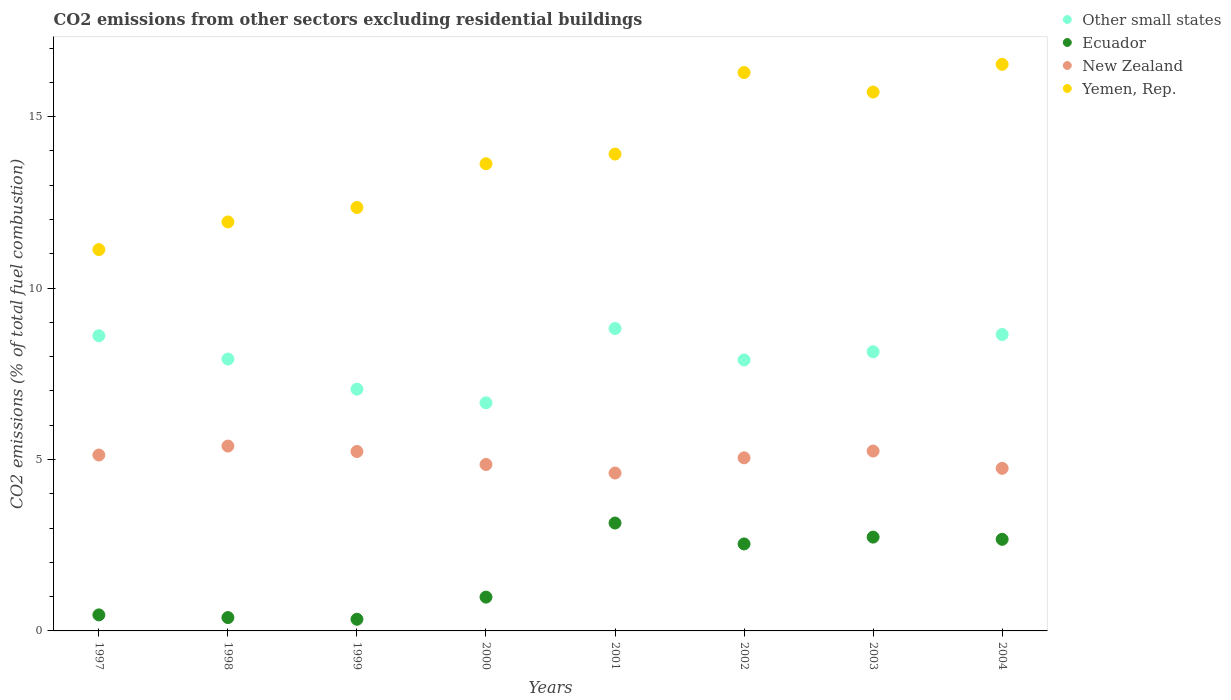How many different coloured dotlines are there?
Keep it short and to the point. 4. What is the total CO2 emitted in Yemen, Rep. in 1999?
Make the answer very short. 12.35. Across all years, what is the maximum total CO2 emitted in New Zealand?
Give a very brief answer. 5.39. Across all years, what is the minimum total CO2 emitted in Yemen, Rep.?
Provide a short and direct response. 11.12. In which year was the total CO2 emitted in New Zealand maximum?
Your answer should be very brief. 1998. What is the total total CO2 emitted in New Zealand in the graph?
Provide a succinct answer. 40.25. What is the difference between the total CO2 emitted in Other small states in 2000 and that in 2003?
Provide a succinct answer. -1.49. What is the difference between the total CO2 emitted in Yemen, Rep. in 2004 and the total CO2 emitted in Other small states in 1997?
Your answer should be compact. 7.92. What is the average total CO2 emitted in Other small states per year?
Offer a terse response. 7.97. In the year 1998, what is the difference between the total CO2 emitted in New Zealand and total CO2 emitted in Ecuador?
Your answer should be compact. 5. In how many years, is the total CO2 emitted in Ecuador greater than 15?
Offer a terse response. 0. What is the ratio of the total CO2 emitted in Ecuador in 1998 to that in 2003?
Your answer should be compact. 0.14. Is the total CO2 emitted in Other small states in 1999 less than that in 2004?
Give a very brief answer. Yes. What is the difference between the highest and the second highest total CO2 emitted in New Zealand?
Offer a very short reply. 0.15. What is the difference between the highest and the lowest total CO2 emitted in New Zealand?
Provide a succinct answer. 0.79. In how many years, is the total CO2 emitted in Other small states greater than the average total CO2 emitted in Other small states taken over all years?
Keep it short and to the point. 4. Is it the case that in every year, the sum of the total CO2 emitted in Other small states and total CO2 emitted in Yemen, Rep.  is greater than the sum of total CO2 emitted in Ecuador and total CO2 emitted in New Zealand?
Make the answer very short. Yes. Is it the case that in every year, the sum of the total CO2 emitted in Yemen, Rep. and total CO2 emitted in Other small states  is greater than the total CO2 emitted in Ecuador?
Provide a succinct answer. Yes. Is the total CO2 emitted in New Zealand strictly greater than the total CO2 emitted in Other small states over the years?
Offer a very short reply. No. How many years are there in the graph?
Your answer should be very brief. 8. What is the difference between two consecutive major ticks on the Y-axis?
Offer a terse response. 5. Does the graph contain any zero values?
Keep it short and to the point. No. Where does the legend appear in the graph?
Your response must be concise. Top right. How many legend labels are there?
Keep it short and to the point. 4. What is the title of the graph?
Keep it short and to the point. CO2 emissions from other sectors excluding residential buildings. What is the label or title of the X-axis?
Offer a very short reply. Years. What is the label or title of the Y-axis?
Your response must be concise. CO2 emissions (% of total fuel combustion). What is the CO2 emissions (% of total fuel combustion) of Other small states in 1997?
Provide a succinct answer. 8.61. What is the CO2 emissions (% of total fuel combustion) of Ecuador in 1997?
Provide a short and direct response. 0.47. What is the CO2 emissions (% of total fuel combustion) in New Zealand in 1997?
Provide a succinct answer. 5.13. What is the CO2 emissions (% of total fuel combustion) of Yemen, Rep. in 1997?
Offer a terse response. 11.12. What is the CO2 emissions (% of total fuel combustion) of Other small states in 1998?
Your answer should be compact. 7.93. What is the CO2 emissions (% of total fuel combustion) in Ecuador in 1998?
Your answer should be compact. 0.39. What is the CO2 emissions (% of total fuel combustion) in New Zealand in 1998?
Keep it short and to the point. 5.39. What is the CO2 emissions (% of total fuel combustion) of Yemen, Rep. in 1998?
Provide a succinct answer. 11.93. What is the CO2 emissions (% of total fuel combustion) in Other small states in 1999?
Offer a terse response. 7.05. What is the CO2 emissions (% of total fuel combustion) of Ecuador in 1999?
Your answer should be very brief. 0.34. What is the CO2 emissions (% of total fuel combustion) in New Zealand in 1999?
Give a very brief answer. 5.23. What is the CO2 emissions (% of total fuel combustion) in Yemen, Rep. in 1999?
Your response must be concise. 12.35. What is the CO2 emissions (% of total fuel combustion) of Other small states in 2000?
Offer a very short reply. 6.65. What is the CO2 emissions (% of total fuel combustion) in Ecuador in 2000?
Your response must be concise. 0.99. What is the CO2 emissions (% of total fuel combustion) of New Zealand in 2000?
Keep it short and to the point. 4.85. What is the CO2 emissions (% of total fuel combustion) in Yemen, Rep. in 2000?
Your response must be concise. 13.63. What is the CO2 emissions (% of total fuel combustion) of Other small states in 2001?
Keep it short and to the point. 8.82. What is the CO2 emissions (% of total fuel combustion) of Ecuador in 2001?
Give a very brief answer. 3.15. What is the CO2 emissions (% of total fuel combustion) of New Zealand in 2001?
Your response must be concise. 4.61. What is the CO2 emissions (% of total fuel combustion) of Yemen, Rep. in 2001?
Your answer should be compact. 13.91. What is the CO2 emissions (% of total fuel combustion) of Other small states in 2002?
Give a very brief answer. 7.9. What is the CO2 emissions (% of total fuel combustion) of Ecuador in 2002?
Give a very brief answer. 2.54. What is the CO2 emissions (% of total fuel combustion) of New Zealand in 2002?
Your answer should be very brief. 5.05. What is the CO2 emissions (% of total fuel combustion) in Yemen, Rep. in 2002?
Your answer should be compact. 16.29. What is the CO2 emissions (% of total fuel combustion) in Other small states in 2003?
Keep it short and to the point. 8.14. What is the CO2 emissions (% of total fuel combustion) in Ecuador in 2003?
Provide a succinct answer. 2.74. What is the CO2 emissions (% of total fuel combustion) in New Zealand in 2003?
Make the answer very short. 5.25. What is the CO2 emissions (% of total fuel combustion) in Yemen, Rep. in 2003?
Your response must be concise. 15.72. What is the CO2 emissions (% of total fuel combustion) of Other small states in 2004?
Provide a short and direct response. 8.65. What is the CO2 emissions (% of total fuel combustion) in Ecuador in 2004?
Ensure brevity in your answer.  2.67. What is the CO2 emissions (% of total fuel combustion) in New Zealand in 2004?
Offer a terse response. 4.74. What is the CO2 emissions (% of total fuel combustion) in Yemen, Rep. in 2004?
Your answer should be compact. 16.53. Across all years, what is the maximum CO2 emissions (% of total fuel combustion) of Other small states?
Provide a succinct answer. 8.82. Across all years, what is the maximum CO2 emissions (% of total fuel combustion) in Ecuador?
Your answer should be very brief. 3.15. Across all years, what is the maximum CO2 emissions (% of total fuel combustion) in New Zealand?
Your answer should be very brief. 5.39. Across all years, what is the maximum CO2 emissions (% of total fuel combustion) of Yemen, Rep.?
Make the answer very short. 16.53. Across all years, what is the minimum CO2 emissions (% of total fuel combustion) in Other small states?
Provide a succinct answer. 6.65. Across all years, what is the minimum CO2 emissions (% of total fuel combustion) of Ecuador?
Offer a terse response. 0.34. Across all years, what is the minimum CO2 emissions (% of total fuel combustion) in New Zealand?
Provide a short and direct response. 4.61. Across all years, what is the minimum CO2 emissions (% of total fuel combustion) of Yemen, Rep.?
Keep it short and to the point. 11.12. What is the total CO2 emissions (% of total fuel combustion) in Other small states in the graph?
Offer a very short reply. 63.76. What is the total CO2 emissions (% of total fuel combustion) of Ecuador in the graph?
Offer a terse response. 13.27. What is the total CO2 emissions (% of total fuel combustion) in New Zealand in the graph?
Your answer should be very brief. 40.25. What is the total CO2 emissions (% of total fuel combustion) in Yemen, Rep. in the graph?
Provide a succinct answer. 111.46. What is the difference between the CO2 emissions (% of total fuel combustion) in Other small states in 1997 and that in 1998?
Offer a terse response. 0.68. What is the difference between the CO2 emissions (% of total fuel combustion) of Ecuador in 1997 and that in 1998?
Give a very brief answer. 0.08. What is the difference between the CO2 emissions (% of total fuel combustion) in New Zealand in 1997 and that in 1998?
Keep it short and to the point. -0.26. What is the difference between the CO2 emissions (% of total fuel combustion) of Yemen, Rep. in 1997 and that in 1998?
Offer a terse response. -0.81. What is the difference between the CO2 emissions (% of total fuel combustion) in Other small states in 1997 and that in 1999?
Give a very brief answer. 1.56. What is the difference between the CO2 emissions (% of total fuel combustion) of Ecuador in 1997 and that in 1999?
Your response must be concise. 0.13. What is the difference between the CO2 emissions (% of total fuel combustion) in New Zealand in 1997 and that in 1999?
Your response must be concise. -0.1. What is the difference between the CO2 emissions (% of total fuel combustion) of Yemen, Rep. in 1997 and that in 1999?
Offer a terse response. -1.23. What is the difference between the CO2 emissions (% of total fuel combustion) in Other small states in 1997 and that in 2000?
Provide a succinct answer. 1.96. What is the difference between the CO2 emissions (% of total fuel combustion) of Ecuador in 1997 and that in 2000?
Give a very brief answer. -0.52. What is the difference between the CO2 emissions (% of total fuel combustion) in New Zealand in 1997 and that in 2000?
Your response must be concise. 0.28. What is the difference between the CO2 emissions (% of total fuel combustion) in Yemen, Rep. in 1997 and that in 2000?
Your answer should be compact. -2.5. What is the difference between the CO2 emissions (% of total fuel combustion) of Other small states in 1997 and that in 2001?
Offer a very short reply. -0.21. What is the difference between the CO2 emissions (% of total fuel combustion) of Ecuador in 1997 and that in 2001?
Provide a short and direct response. -2.68. What is the difference between the CO2 emissions (% of total fuel combustion) in New Zealand in 1997 and that in 2001?
Offer a very short reply. 0.52. What is the difference between the CO2 emissions (% of total fuel combustion) of Yemen, Rep. in 1997 and that in 2001?
Keep it short and to the point. -2.79. What is the difference between the CO2 emissions (% of total fuel combustion) of Other small states in 1997 and that in 2002?
Provide a short and direct response. 0.71. What is the difference between the CO2 emissions (% of total fuel combustion) in Ecuador in 1997 and that in 2002?
Offer a terse response. -2.07. What is the difference between the CO2 emissions (% of total fuel combustion) in New Zealand in 1997 and that in 2002?
Your answer should be very brief. 0.08. What is the difference between the CO2 emissions (% of total fuel combustion) in Yemen, Rep. in 1997 and that in 2002?
Keep it short and to the point. -5.16. What is the difference between the CO2 emissions (% of total fuel combustion) of Other small states in 1997 and that in 2003?
Make the answer very short. 0.47. What is the difference between the CO2 emissions (% of total fuel combustion) in Ecuador in 1997 and that in 2003?
Give a very brief answer. -2.27. What is the difference between the CO2 emissions (% of total fuel combustion) of New Zealand in 1997 and that in 2003?
Give a very brief answer. -0.12. What is the difference between the CO2 emissions (% of total fuel combustion) of Yemen, Rep. in 1997 and that in 2003?
Your answer should be compact. -4.59. What is the difference between the CO2 emissions (% of total fuel combustion) of Other small states in 1997 and that in 2004?
Give a very brief answer. -0.04. What is the difference between the CO2 emissions (% of total fuel combustion) of Ecuador in 1997 and that in 2004?
Your answer should be compact. -2.2. What is the difference between the CO2 emissions (% of total fuel combustion) in New Zealand in 1997 and that in 2004?
Offer a terse response. 0.39. What is the difference between the CO2 emissions (% of total fuel combustion) of Yemen, Rep. in 1997 and that in 2004?
Your answer should be very brief. -5.4. What is the difference between the CO2 emissions (% of total fuel combustion) in Other small states in 1998 and that in 1999?
Keep it short and to the point. 0.88. What is the difference between the CO2 emissions (% of total fuel combustion) in Ecuador in 1998 and that in 1999?
Offer a terse response. 0.05. What is the difference between the CO2 emissions (% of total fuel combustion) of New Zealand in 1998 and that in 1999?
Keep it short and to the point. 0.16. What is the difference between the CO2 emissions (% of total fuel combustion) in Yemen, Rep. in 1998 and that in 1999?
Give a very brief answer. -0.42. What is the difference between the CO2 emissions (% of total fuel combustion) of Other small states in 1998 and that in 2000?
Offer a terse response. 1.28. What is the difference between the CO2 emissions (% of total fuel combustion) of Ecuador in 1998 and that in 2000?
Offer a terse response. -0.6. What is the difference between the CO2 emissions (% of total fuel combustion) in New Zealand in 1998 and that in 2000?
Ensure brevity in your answer.  0.54. What is the difference between the CO2 emissions (% of total fuel combustion) in Yemen, Rep. in 1998 and that in 2000?
Ensure brevity in your answer.  -1.7. What is the difference between the CO2 emissions (% of total fuel combustion) of Other small states in 1998 and that in 2001?
Your answer should be compact. -0.89. What is the difference between the CO2 emissions (% of total fuel combustion) in Ecuador in 1998 and that in 2001?
Your answer should be very brief. -2.76. What is the difference between the CO2 emissions (% of total fuel combustion) in New Zealand in 1998 and that in 2001?
Your answer should be compact. 0.79. What is the difference between the CO2 emissions (% of total fuel combustion) of Yemen, Rep. in 1998 and that in 2001?
Give a very brief answer. -1.98. What is the difference between the CO2 emissions (% of total fuel combustion) in Other small states in 1998 and that in 2002?
Your answer should be very brief. 0.03. What is the difference between the CO2 emissions (% of total fuel combustion) in Ecuador in 1998 and that in 2002?
Keep it short and to the point. -2.15. What is the difference between the CO2 emissions (% of total fuel combustion) of New Zealand in 1998 and that in 2002?
Ensure brevity in your answer.  0.34. What is the difference between the CO2 emissions (% of total fuel combustion) of Yemen, Rep. in 1998 and that in 2002?
Ensure brevity in your answer.  -4.36. What is the difference between the CO2 emissions (% of total fuel combustion) of Other small states in 1998 and that in 2003?
Ensure brevity in your answer.  -0.21. What is the difference between the CO2 emissions (% of total fuel combustion) of Ecuador in 1998 and that in 2003?
Make the answer very short. -2.35. What is the difference between the CO2 emissions (% of total fuel combustion) in New Zealand in 1998 and that in 2003?
Your answer should be compact. 0.15. What is the difference between the CO2 emissions (% of total fuel combustion) of Yemen, Rep. in 1998 and that in 2003?
Your response must be concise. -3.79. What is the difference between the CO2 emissions (% of total fuel combustion) in Other small states in 1998 and that in 2004?
Ensure brevity in your answer.  -0.72. What is the difference between the CO2 emissions (% of total fuel combustion) of Ecuador in 1998 and that in 2004?
Make the answer very short. -2.28. What is the difference between the CO2 emissions (% of total fuel combustion) of New Zealand in 1998 and that in 2004?
Your answer should be very brief. 0.65. What is the difference between the CO2 emissions (% of total fuel combustion) of Yemen, Rep. in 1998 and that in 2004?
Your answer should be very brief. -4.6. What is the difference between the CO2 emissions (% of total fuel combustion) of Other small states in 1999 and that in 2000?
Offer a very short reply. 0.4. What is the difference between the CO2 emissions (% of total fuel combustion) of Ecuador in 1999 and that in 2000?
Offer a very short reply. -0.65. What is the difference between the CO2 emissions (% of total fuel combustion) in New Zealand in 1999 and that in 2000?
Provide a short and direct response. 0.38. What is the difference between the CO2 emissions (% of total fuel combustion) of Yemen, Rep. in 1999 and that in 2000?
Ensure brevity in your answer.  -1.28. What is the difference between the CO2 emissions (% of total fuel combustion) in Other small states in 1999 and that in 2001?
Give a very brief answer. -1.77. What is the difference between the CO2 emissions (% of total fuel combustion) in Ecuador in 1999 and that in 2001?
Keep it short and to the point. -2.81. What is the difference between the CO2 emissions (% of total fuel combustion) in New Zealand in 1999 and that in 2001?
Provide a succinct answer. 0.63. What is the difference between the CO2 emissions (% of total fuel combustion) in Yemen, Rep. in 1999 and that in 2001?
Ensure brevity in your answer.  -1.56. What is the difference between the CO2 emissions (% of total fuel combustion) in Other small states in 1999 and that in 2002?
Your response must be concise. -0.85. What is the difference between the CO2 emissions (% of total fuel combustion) in Ecuador in 1999 and that in 2002?
Give a very brief answer. -2.2. What is the difference between the CO2 emissions (% of total fuel combustion) in New Zealand in 1999 and that in 2002?
Your response must be concise. 0.18. What is the difference between the CO2 emissions (% of total fuel combustion) in Yemen, Rep. in 1999 and that in 2002?
Provide a succinct answer. -3.94. What is the difference between the CO2 emissions (% of total fuel combustion) of Other small states in 1999 and that in 2003?
Your answer should be very brief. -1.09. What is the difference between the CO2 emissions (% of total fuel combustion) in Ecuador in 1999 and that in 2003?
Ensure brevity in your answer.  -2.4. What is the difference between the CO2 emissions (% of total fuel combustion) in New Zealand in 1999 and that in 2003?
Your answer should be compact. -0.01. What is the difference between the CO2 emissions (% of total fuel combustion) of Yemen, Rep. in 1999 and that in 2003?
Your answer should be compact. -3.37. What is the difference between the CO2 emissions (% of total fuel combustion) of Other small states in 1999 and that in 2004?
Provide a succinct answer. -1.59. What is the difference between the CO2 emissions (% of total fuel combustion) in Ecuador in 1999 and that in 2004?
Offer a very short reply. -2.33. What is the difference between the CO2 emissions (% of total fuel combustion) of New Zealand in 1999 and that in 2004?
Give a very brief answer. 0.49. What is the difference between the CO2 emissions (% of total fuel combustion) in Yemen, Rep. in 1999 and that in 2004?
Make the answer very short. -4.18. What is the difference between the CO2 emissions (% of total fuel combustion) in Other small states in 2000 and that in 2001?
Offer a very short reply. -2.17. What is the difference between the CO2 emissions (% of total fuel combustion) of Ecuador in 2000 and that in 2001?
Give a very brief answer. -2.16. What is the difference between the CO2 emissions (% of total fuel combustion) in New Zealand in 2000 and that in 2001?
Offer a very short reply. 0.25. What is the difference between the CO2 emissions (% of total fuel combustion) of Yemen, Rep. in 2000 and that in 2001?
Ensure brevity in your answer.  -0.28. What is the difference between the CO2 emissions (% of total fuel combustion) of Other small states in 2000 and that in 2002?
Provide a succinct answer. -1.25. What is the difference between the CO2 emissions (% of total fuel combustion) in Ecuador in 2000 and that in 2002?
Your answer should be very brief. -1.55. What is the difference between the CO2 emissions (% of total fuel combustion) of New Zealand in 2000 and that in 2002?
Offer a very short reply. -0.19. What is the difference between the CO2 emissions (% of total fuel combustion) in Yemen, Rep. in 2000 and that in 2002?
Your answer should be very brief. -2.66. What is the difference between the CO2 emissions (% of total fuel combustion) in Other small states in 2000 and that in 2003?
Your answer should be compact. -1.49. What is the difference between the CO2 emissions (% of total fuel combustion) in Ecuador in 2000 and that in 2003?
Offer a terse response. -1.75. What is the difference between the CO2 emissions (% of total fuel combustion) in New Zealand in 2000 and that in 2003?
Your answer should be compact. -0.39. What is the difference between the CO2 emissions (% of total fuel combustion) of Yemen, Rep. in 2000 and that in 2003?
Ensure brevity in your answer.  -2.09. What is the difference between the CO2 emissions (% of total fuel combustion) of Other small states in 2000 and that in 2004?
Give a very brief answer. -1.99. What is the difference between the CO2 emissions (% of total fuel combustion) in Ecuador in 2000 and that in 2004?
Offer a very short reply. -1.69. What is the difference between the CO2 emissions (% of total fuel combustion) of New Zealand in 2000 and that in 2004?
Your response must be concise. 0.11. What is the difference between the CO2 emissions (% of total fuel combustion) of Yemen, Rep. in 2000 and that in 2004?
Ensure brevity in your answer.  -2.9. What is the difference between the CO2 emissions (% of total fuel combustion) in Other small states in 2001 and that in 2002?
Your answer should be very brief. 0.92. What is the difference between the CO2 emissions (% of total fuel combustion) of Ecuador in 2001 and that in 2002?
Your response must be concise. 0.61. What is the difference between the CO2 emissions (% of total fuel combustion) of New Zealand in 2001 and that in 2002?
Your answer should be very brief. -0.44. What is the difference between the CO2 emissions (% of total fuel combustion) in Yemen, Rep. in 2001 and that in 2002?
Your answer should be very brief. -2.38. What is the difference between the CO2 emissions (% of total fuel combustion) in Other small states in 2001 and that in 2003?
Make the answer very short. 0.68. What is the difference between the CO2 emissions (% of total fuel combustion) of Ecuador in 2001 and that in 2003?
Offer a terse response. 0.41. What is the difference between the CO2 emissions (% of total fuel combustion) in New Zealand in 2001 and that in 2003?
Give a very brief answer. -0.64. What is the difference between the CO2 emissions (% of total fuel combustion) of Yemen, Rep. in 2001 and that in 2003?
Offer a terse response. -1.81. What is the difference between the CO2 emissions (% of total fuel combustion) in Other small states in 2001 and that in 2004?
Provide a short and direct response. 0.18. What is the difference between the CO2 emissions (% of total fuel combustion) in Ecuador in 2001 and that in 2004?
Make the answer very short. 0.48. What is the difference between the CO2 emissions (% of total fuel combustion) in New Zealand in 2001 and that in 2004?
Offer a very short reply. -0.14. What is the difference between the CO2 emissions (% of total fuel combustion) in Yemen, Rep. in 2001 and that in 2004?
Give a very brief answer. -2.62. What is the difference between the CO2 emissions (% of total fuel combustion) of Other small states in 2002 and that in 2003?
Provide a succinct answer. -0.24. What is the difference between the CO2 emissions (% of total fuel combustion) in Ecuador in 2002 and that in 2003?
Your response must be concise. -0.2. What is the difference between the CO2 emissions (% of total fuel combustion) in New Zealand in 2002 and that in 2003?
Offer a terse response. -0.2. What is the difference between the CO2 emissions (% of total fuel combustion) of Yemen, Rep. in 2002 and that in 2003?
Offer a very short reply. 0.57. What is the difference between the CO2 emissions (% of total fuel combustion) of Other small states in 2002 and that in 2004?
Provide a succinct answer. -0.74. What is the difference between the CO2 emissions (% of total fuel combustion) of Ecuador in 2002 and that in 2004?
Provide a short and direct response. -0.13. What is the difference between the CO2 emissions (% of total fuel combustion) of New Zealand in 2002 and that in 2004?
Keep it short and to the point. 0.31. What is the difference between the CO2 emissions (% of total fuel combustion) of Yemen, Rep. in 2002 and that in 2004?
Provide a short and direct response. -0.24. What is the difference between the CO2 emissions (% of total fuel combustion) of Other small states in 2003 and that in 2004?
Your answer should be very brief. -0.5. What is the difference between the CO2 emissions (% of total fuel combustion) of Ecuador in 2003 and that in 2004?
Your answer should be compact. 0.07. What is the difference between the CO2 emissions (% of total fuel combustion) of New Zealand in 2003 and that in 2004?
Provide a short and direct response. 0.5. What is the difference between the CO2 emissions (% of total fuel combustion) of Yemen, Rep. in 2003 and that in 2004?
Keep it short and to the point. -0.81. What is the difference between the CO2 emissions (% of total fuel combustion) in Other small states in 1997 and the CO2 emissions (% of total fuel combustion) in Ecuador in 1998?
Ensure brevity in your answer.  8.22. What is the difference between the CO2 emissions (% of total fuel combustion) in Other small states in 1997 and the CO2 emissions (% of total fuel combustion) in New Zealand in 1998?
Give a very brief answer. 3.22. What is the difference between the CO2 emissions (% of total fuel combustion) of Other small states in 1997 and the CO2 emissions (% of total fuel combustion) of Yemen, Rep. in 1998?
Ensure brevity in your answer.  -3.32. What is the difference between the CO2 emissions (% of total fuel combustion) of Ecuador in 1997 and the CO2 emissions (% of total fuel combustion) of New Zealand in 1998?
Your answer should be very brief. -4.92. What is the difference between the CO2 emissions (% of total fuel combustion) in Ecuador in 1997 and the CO2 emissions (% of total fuel combustion) in Yemen, Rep. in 1998?
Your answer should be compact. -11.46. What is the difference between the CO2 emissions (% of total fuel combustion) in New Zealand in 1997 and the CO2 emissions (% of total fuel combustion) in Yemen, Rep. in 1998?
Keep it short and to the point. -6.8. What is the difference between the CO2 emissions (% of total fuel combustion) in Other small states in 1997 and the CO2 emissions (% of total fuel combustion) in Ecuador in 1999?
Offer a very short reply. 8.27. What is the difference between the CO2 emissions (% of total fuel combustion) in Other small states in 1997 and the CO2 emissions (% of total fuel combustion) in New Zealand in 1999?
Your response must be concise. 3.38. What is the difference between the CO2 emissions (% of total fuel combustion) of Other small states in 1997 and the CO2 emissions (% of total fuel combustion) of Yemen, Rep. in 1999?
Ensure brevity in your answer.  -3.74. What is the difference between the CO2 emissions (% of total fuel combustion) in Ecuador in 1997 and the CO2 emissions (% of total fuel combustion) in New Zealand in 1999?
Offer a very short reply. -4.77. What is the difference between the CO2 emissions (% of total fuel combustion) of Ecuador in 1997 and the CO2 emissions (% of total fuel combustion) of Yemen, Rep. in 1999?
Provide a short and direct response. -11.88. What is the difference between the CO2 emissions (% of total fuel combustion) of New Zealand in 1997 and the CO2 emissions (% of total fuel combustion) of Yemen, Rep. in 1999?
Your answer should be very brief. -7.22. What is the difference between the CO2 emissions (% of total fuel combustion) of Other small states in 1997 and the CO2 emissions (% of total fuel combustion) of Ecuador in 2000?
Make the answer very short. 7.62. What is the difference between the CO2 emissions (% of total fuel combustion) of Other small states in 1997 and the CO2 emissions (% of total fuel combustion) of New Zealand in 2000?
Provide a short and direct response. 3.76. What is the difference between the CO2 emissions (% of total fuel combustion) in Other small states in 1997 and the CO2 emissions (% of total fuel combustion) in Yemen, Rep. in 2000?
Your answer should be very brief. -5.02. What is the difference between the CO2 emissions (% of total fuel combustion) of Ecuador in 1997 and the CO2 emissions (% of total fuel combustion) of New Zealand in 2000?
Offer a terse response. -4.39. What is the difference between the CO2 emissions (% of total fuel combustion) of Ecuador in 1997 and the CO2 emissions (% of total fuel combustion) of Yemen, Rep. in 2000?
Give a very brief answer. -13.16. What is the difference between the CO2 emissions (% of total fuel combustion) in New Zealand in 1997 and the CO2 emissions (% of total fuel combustion) in Yemen, Rep. in 2000?
Give a very brief answer. -8.5. What is the difference between the CO2 emissions (% of total fuel combustion) of Other small states in 1997 and the CO2 emissions (% of total fuel combustion) of Ecuador in 2001?
Offer a very short reply. 5.46. What is the difference between the CO2 emissions (% of total fuel combustion) of Other small states in 1997 and the CO2 emissions (% of total fuel combustion) of New Zealand in 2001?
Offer a terse response. 4. What is the difference between the CO2 emissions (% of total fuel combustion) of Other small states in 1997 and the CO2 emissions (% of total fuel combustion) of Yemen, Rep. in 2001?
Your answer should be very brief. -5.3. What is the difference between the CO2 emissions (% of total fuel combustion) in Ecuador in 1997 and the CO2 emissions (% of total fuel combustion) in New Zealand in 2001?
Provide a short and direct response. -4.14. What is the difference between the CO2 emissions (% of total fuel combustion) of Ecuador in 1997 and the CO2 emissions (% of total fuel combustion) of Yemen, Rep. in 2001?
Your answer should be very brief. -13.44. What is the difference between the CO2 emissions (% of total fuel combustion) of New Zealand in 1997 and the CO2 emissions (% of total fuel combustion) of Yemen, Rep. in 2001?
Your response must be concise. -8.78. What is the difference between the CO2 emissions (% of total fuel combustion) of Other small states in 1997 and the CO2 emissions (% of total fuel combustion) of Ecuador in 2002?
Give a very brief answer. 6.07. What is the difference between the CO2 emissions (% of total fuel combustion) of Other small states in 1997 and the CO2 emissions (% of total fuel combustion) of New Zealand in 2002?
Your answer should be compact. 3.56. What is the difference between the CO2 emissions (% of total fuel combustion) of Other small states in 1997 and the CO2 emissions (% of total fuel combustion) of Yemen, Rep. in 2002?
Provide a succinct answer. -7.68. What is the difference between the CO2 emissions (% of total fuel combustion) in Ecuador in 1997 and the CO2 emissions (% of total fuel combustion) in New Zealand in 2002?
Your answer should be compact. -4.58. What is the difference between the CO2 emissions (% of total fuel combustion) of Ecuador in 1997 and the CO2 emissions (% of total fuel combustion) of Yemen, Rep. in 2002?
Offer a very short reply. -15.82. What is the difference between the CO2 emissions (% of total fuel combustion) of New Zealand in 1997 and the CO2 emissions (% of total fuel combustion) of Yemen, Rep. in 2002?
Your answer should be very brief. -11.16. What is the difference between the CO2 emissions (% of total fuel combustion) in Other small states in 1997 and the CO2 emissions (% of total fuel combustion) in Ecuador in 2003?
Make the answer very short. 5.87. What is the difference between the CO2 emissions (% of total fuel combustion) of Other small states in 1997 and the CO2 emissions (% of total fuel combustion) of New Zealand in 2003?
Your response must be concise. 3.36. What is the difference between the CO2 emissions (% of total fuel combustion) in Other small states in 1997 and the CO2 emissions (% of total fuel combustion) in Yemen, Rep. in 2003?
Keep it short and to the point. -7.11. What is the difference between the CO2 emissions (% of total fuel combustion) in Ecuador in 1997 and the CO2 emissions (% of total fuel combustion) in New Zealand in 2003?
Keep it short and to the point. -4.78. What is the difference between the CO2 emissions (% of total fuel combustion) in Ecuador in 1997 and the CO2 emissions (% of total fuel combustion) in Yemen, Rep. in 2003?
Ensure brevity in your answer.  -15.25. What is the difference between the CO2 emissions (% of total fuel combustion) in New Zealand in 1997 and the CO2 emissions (% of total fuel combustion) in Yemen, Rep. in 2003?
Offer a terse response. -10.59. What is the difference between the CO2 emissions (% of total fuel combustion) of Other small states in 1997 and the CO2 emissions (% of total fuel combustion) of Ecuador in 2004?
Provide a succinct answer. 5.94. What is the difference between the CO2 emissions (% of total fuel combustion) in Other small states in 1997 and the CO2 emissions (% of total fuel combustion) in New Zealand in 2004?
Provide a short and direct response. 3.87. What is the difference between the CO2 emissions (% of total fuel combustion) in Other small states in 1997 and the CO2 emissions (% of total fuel combustion) in Yemen, Rep. in 2004?
Offer a very short reply. -7.92. What is the difference between the CO2 emissions (% of total fuel combustion) in Ecuador in 1997 and the CO2 emissions (% of total fuel combustion) in New Zealand in 2004?
Your response must be concise. -4.27. What is the difference between the CO2 emissions (% of total fuel combustion) in Ecuador in 1997 and the CO2 emissions (% of total fuel combustion) in Yemen, Rep. in 2004?
Offer a very short reply. -16.06. What is the difference between the CO2 emissions (% of total fuel combustion) in New Zealand in 1997 and the CO2 emissions (% of total fuel combustion) in Yemen, Rep. in 2004?
Your answer should be very brief. -11.4. What is the difference between the CO2 emissions (% of total fuel combustion) of Other small states in 1998 and the CO2 emissions (% of total fuel combustion) of Ecuador in 1999?
Make the answer very short. 7.59. What is the difference between the CO2 emissions (% of total fuel combustion) in Other small states in 1998 and the CO2 emissions (% of total fuel combustion) in New Zealand in 1999?
Ensure brevity in your answer.  2.7. What is the difference between the CO2 emissions (% of total fuel combustion) of Other small states in 1998 and the CO2 emissions (% of total fuel combustion) of Yemen, Rep. in 1999?
Offer a terse response. -4.42. What is the difference between the CO2 emissions (% of total fuel combustion) in Ecuador in 1998 and the CO2 emissions (% of total fuel combustion) in New Zealand in 1999?
Offer a terse response. -4.84. What is the difference between the CO2 emissions (% of total fuel combustion) in Ecuador in 1998 and the CO2 emissions (% of total fuel combustion) in Yemen, Rep. in 1999?
Your answer should be very brief. -11.96. What is the difference between the CO2 emissions (% of total fuel combustion) in New Zealand in 1998 and the CO2 emissions (% of total fuel combustion) in Yemen, Rep. in 1999?
Your answer should be compact. -6.96. What is the difference between the CO2 emissions (% of total fuel combustion) in Other small states in 1998 and the CO2 emissions (% of total fuel combustion) in Ecuador in 2000?
Provide a short and direct response. 6.94. What is the difference between the CO2 emissions (% of total fuel combustion) in Other small states in 1998 and the CO2 emissions (% of total fuel combustion) in New Zealand in 2000?
Offer a terse response. 3.08. What is the difference between the CO2 emissions (% of total fuel combustion) in Other small states in 1998 and the CO2 emissions (% of total fuel combustion) in Yemen, Rep. in 2000?
Provide a succinct answer. -5.7. What is the difference between the CO2 emissions (% of total fuel combustion) of Ecuador in 1998 and the CO2 emissions (% of total fuel combustion) of New Zealand in 2000?
Provide a short and direct response. -4.46. What is the difference between the CO2 emissions (% of total fuel combustion) in Ecuador in 1998 and the CO2 emissions (% of total fuel combustion) in Yemen, Rep. in 2000?
Offer a terse response. -13.24. What is the difference between the CO2 emissions (% of total fuel combustion) of New Zealand in 1998 and the CO2 emissions (% of total fuel combustion) of Yemen, Rep. in 2000?
Make the answer very short. -8.23. What is the difference between the CO2 emissions (% of total fuel combustion) in Other small states in 1998 and the CO2 emissions (% of total fuel combustion) in Ecuador in 2001?
Provide a succinct answer. 4.78. What is the difference between the CO2 emissions (% of total fuel combustion) of Other small states in 1998 and the CO2 emissions (% of total fuel combustion) of New Zealand in 2001?
Give a very brief answer. 3.32. What is the difference between the CO2 emissions (% of total fuel combustion) of Other small states in 1998 and the CO2 emissions (% of total fuel combustion) of Yemen, Rep. in 2001?
Ensure brevity in your answer.  -5.98. What is the difference between the CO2 emissions (% of total fuel combustion) in Ecuador in 1998 and the CO2 emissions (% of total fuel combustion) in New Zealand in 2001?
Provide a short and direct response. -4.22. What is the difference between the CO2 emissions (% of total fuel combustion) of Ecuador in 1998 and the CO2 emissions (% of total fuel combustion) of Yemen, Rep. in 2001?
Ensure brevity in your answer.  -13.52. What is the difference between the CO2 emissions (% of total fuel combustion) in New Zealand in 1998 and the CO2 emissions (% of total fuel combustion) in Yemen, Rep. in 2001?
Your response must be concise. -8.52. What is the difference between the CO2 emissions (% of total fuel combustion) of Other small states in 1998 and the CO2 emissions (% of total fuel combustion) of Ecuador in 2002?
Your answer should be very brief. 5.39. What is the difference between the CO2 emissions (% of total fuel combustion) in Other small states in 1998 and the CO2 emissions (% of total fuel combustion) in New Zealand in 2002?
Your response must be concise. 2.88. What is the difference between the CO2 emissions (% of total fuel combustion) in Other small states in 1998 and the CO2 emissions (% of total fuel combustion) in Yemen, Rep. in 2002?
Offer a very short reply. -8.36. What is the difference between the CO2 emissions (% of total fuel combustion) of Ecuador in 1998 and the CO2 emissions (% of total fuel combustion) of New Zealand in 2002?
Give a very brief answer. -4.66. What is the difference between the CO2 emissions (% of total fuel combustion) of Ecuador in 1998 and the CO2 emissions (% of total fuel combustion) of Yemen, Rep. in 2002?
Your answer should be very brief. -15.9. What is the difference between the CO2 emissions (% of total fuel combustion) of New Zealand in 1998 and the CO2 emissions (% of total fuel combustion) of Yemen, Rep. in 2002?
Give a very brief answer. -10.89. What is the difference between the CO2 emissions (% of total fuel combustion) in Other small states in 1998 and the CO2 emissions (% of total fuel combustion) in Ecuador in 2003?
Provide a short and direct response. 5.19. What is the difference between the CO2 emissions (% of total fuel combustion) of Other small states in 1998 and the CO2 emissions (% of total fuel combustion) of New Zealand in 2003?
Provide a short and direct response. 2.68. What is the difference between the CO2 emissions (% of total fuel combustion) of Other small states in 1998 and the CO2 emissions (% of total fuel combustion) of Yemen, Rep. in 2003?
Ensure brevity in your answer.  -7.79. What is the difference between the CO2 emissions (% of total fuel combustion) in Ecuador in 1998 and the CO2 emissions (% of total fuel combustion) in New Zealand in 2003?
Your response must be concise. -4.86. What is the difference between the CO2 emissions (% of total fuel combustion) in Ecuador in 1998 and the CO2 emissions (% of total fuel combustion) in Yemen, Rep. in 2003?
Give a very brief answer. -15.33. What is the difference between the CO2 emissions (% of total fuel combustion) of New Zealand in 1998 and the CO2 emissions (% of total fuel combustion) of Yemen, Rep. in 2003?
Your answer should be compact. -10.32. What is the difference between the CO2 emissions (% of total fuel combustion) of Other small states in 1998 and the CO2 emissions (% of total fuel combustion) of Ecuador in 2004?
Provide a short and direct response. 5.26. What is the difference between the CO2 emissions (% of total fuel combustion) in Other small states in 1998 and the CO2 emissions (% of total fuel combustion) in New Zealand in 2004?
Keep it short and to the point. 3.19. What is the difference between the CO2 emissions (% of total fuel combustion) in Other small states in 1998 and the CO2 emissions (% of total fuel combustion) in Yemen, Rep. in 2004?
Offer a terse response. -8.6. What is the difference between the CO2 emissions (% of total fuel combustion) in Ecuador in 1998 and the CO2 emissions (% of total fuel combustion) in New Zealand in 2004?
Offer a very short reply. -4.35. What is the difference between the CO2 emissions (% of total fuel combustion) in Ecuador in 1998 and the CO2 emissions (% of total fuel combustion) in Yemen, Rep. in 2004?
Your answer should be compact. -16.14. What is the difference between the CO2 emissions (% of total fuel combustion) in New Zealand in 1998 and the CO2 emissions (% of total fuel combustion) in Yemen, Rep. in 2004?
Make the answer very short. -11.13. What is the difference between the CO2 emissions (% of total fuel combustion) of Other small states in 1999 and the CO2 emissions (% of total fuel combustion) of Ecuador in 2000?
Provide a short and direct response. 6.07. What is the difference between the CO2 emissions (% of total fuel combustion) of Other small states in 1999 and the CO2 emissions (% of total fuel combustion) of New Zealand in 2000?
Make the answer very short. 2.2. What is the difference between the CO2 emissions (% of total fuel combustion) of Other small states in 1999 and the CO2 emissions (% of total fuel combustion) of Yemen, Rep. in 2000?
Keep it short and to the point. -6.57. What is the difference between the CO2 emissions (% of total fuel combustion) of Ecuador in 1999 and the CO2 emissions (% of total fuel combustion) of New Zealand in 2000?
Provide a succinct answer. -4.51. What is the difference between the CO2 emissions (% of total fuel combustion) of Ecuador in 1999 and the CO2 emissions (% of total fuel combustion) of Yemen, Rep. in 2000?
Give a very brief answer. -13.29. What is the difference between the CO2 emissions (% of total fuel combustion) in New Zealand in 1999 and the CO2 emissions (% of total fuel combustion) in Yemen, Rep. in 2000?
Make the answer very short. -8.39. What is the difference between the CO2 emissions (% of total fuel combustion) of Other small states in 1999 and the CO2 emissions (% of total fuel combustion) of Ecuador in 2001?
Keep it short and to the point. 3.9. What is the difference between the CO2 emissions (% of total fuel combustion) of Other small states in 1999 and the CO2 emissions (% of total fuel combustion) of New Zealand in 2001?
Offer a very short reply. 2.45. What is the difference between the CO2 emissions (% of total fuel combustion) in Other small states in 1999 and the CO2 emissions (% of total fuel combustion) in Yemen, Rep. in 2001?
Your answer should be very brief. -6.86. What is the difference between the CO2 emissions (% of total fuel combustion) of Ecuador in 1999 and the CO2 emissions (% of total fuel combustion) of New Zealand in 2001?
Make the answer very short. -4.26. What is the difference between the CO2 emissions (% of total fuel combustion) of Ecuador in 1999 and the CO2 emissions (% of total fuel combustion) of Yemen, Rep. in 2001?
Your answer should be very brief. -13.57. What is the difference between the CO2 emissions (% of total fuel combustion) in New Zealand in 1999 and the CO2 emissions (% of total fuel combustion) in Yemen, Rep. in 2001?
Give a very brief answer. -8.68. What is the difference between the CO2 emissions (% of total fuel combustion) in Other small states in 1999 and the CO2 emissions (% of total fuel combustion) in Ecuador in 2002?
Give a very brief answer. 4.51. What is the difference between the CO2 emissions (% of total fuel combustion) of Other small states in 1999 and the CO2 emissions (% of total fuel combustion) of New Zealand in 2002?
Provide a succinct answer. 2. What is the difference between the CO2 emissions (% of total fuel combustion) in Other small states in 1999 and the CO2 emissions (% of total fuel combustion) in Yemen, Rep. in 2002?
Keep it short and to the point. -9.23. What is the difference between the CO2 emissions (% of total fuel combustion) of Ecuador in 1999 and the CO2 emissions (% of total fuel combustion) of New Zealand in 2002?
Make the answer very short. -4.71. What is the difference between the CO2 emissions (% of total fuel combustion) in Ecuador in 1999 and the CO2 emissions (% of total fuel combustion) in Yemen, Rep. in 2002?
Provide a short and direct response. -15.95. What is the difference between the CO2 emissions (% of total fuel combustion) of New Zealand in 1999 and the CO2 emissions (% of total fuel combustion) of Yemen, Rep. in 2002?
Make the answer very short. -11.05. What is the difference between the CO2 emissions (% of total fuel combustion) of Other small states in 1999 and the CO2 emissions (% of total fuel combustion) of Ecuador in 2003?
Keep it short and to the point. 4.31. What is the difference between the CO2 emissions (% of total fuel combustion) in Other small states in 1999 and the CO2 emissions (% of total fuel combustion) in New Zealand in 2003?
Provide a short and direct response. 1.81. What is the difference between the CO2 emissions (% of total fuel combustion) in Other small states in 1999 and the CO2 emissions (% of total fuel combustion) in Yemen, Rep. in 2003?
Provide a succinct answer. -8.67. What is the difference between the CO2 emissions (% of total fuel combustion) of Ecuador in 1999 and the CO2 emissions (% of total fuel combustion) of New Zealand in 2003?
Your response must be concise. -4.91. What is the difference between the CO2 emissions (% of total fuel combustion) in Ecuador in 1999 and the CO2 emissions (% of total fuel combustion) in Yemen, Rep. in 2003?
Give a very brief answer. -15.38. What is the difference between the CO2 emissions (% of total fuel combustion) of New Zealand in 1999 and the CO2 emissions (% of total fuel combustion) of Yemen, Rep. in 2003?
Your answer should be compact. -10.48. What is the difference between the CO2 emissions (% of total fuel combustion) in Other small states in 1999 and the CO2 emissions (% of total fuel combustion) in Ecuador in 2004?
Your response must be concise. 4.38. What is the difference between the CO2 emissions (% of total fuel combustion) of Other small states in 1999 and the CO2 emissions (% of total fuel combustion) of New Zealand in 2004?
Give a very brief answer. 2.31. What is the difference between the CO2 emissions (% of total fuel combustion) in Other small states in 1999 and the CO2 emissions (% of total fuel combustion) in Yemen, Rep. in 2004?
Your response must be concise. -9.47. What is the difference between the CO2 emissions (% of total fuel combustion) of Ecuador in 1999 and the CO2 emissions (% of total fuel combustion) of New Zealand in 2004?
Keep it short and to the point. -4.4. What is the difference between the CO2 emissions (% of total fuel combustion) of Ecuador in 1999 and the CO2 emissions (% of total fuel combustion) of Yemen, Rep. in 2004?
Your answer should be very brief. -16.18. What is the difference between the CO2 emissions (% of total fuel combustion) of New Zealand in 1999 and the CO2 emissions (% of total fuel combustion) of Yemen, Rep. in 2004?
Give a very brief answer. -11.29. What is the difference between the CO2 emissions (% of total fuel combustion) in Other small states in 2000 and the CO2 emissions (% of total fuel combustion) in Ecuador in 2001?
Ensure brevity in your answer.  3.51. What is the difference between the CO2 emissions (% of total fuel combustion) of Other small states in 2000 and the CO2 emissions (% of total fuel combustion) of New Zealand in 2001?
Keep it short and to the point. 2.05. What is the difference between the CO2 emissions (% of total fuel combustion) of Other small states in 2000 and the CO2 emissions (% of total fuel combustion) of Yemen, Rep. in 2001?
Keep it short and to the point. -7.26. What is the difference between the CO2 emissions (% of total fuel combustion) of Ecuador in 2000 and the CO2 emissions (% of total fuel combustion) of New Zealand in 2001?
Make the answer very short. -3.62. What is the difference between the CO2 emissions (% of total fuel combustion) in Ecuador in 2000 and the CO2 emissions (% of total fuel combustion) in Yemen, Rep. in 2001?
Offer a very short reply. -12.92. What is the difference between the CO2 emissions (% of total fuel combustion) of New Zealand in 2000 and the CO2 emissions (% of total fuel combustion) of Yemen, Rep. in 2001?
Give a very brief answer. -9.05. What is the difference between the CO2 emissions (% of total fuel combustion) in Other small states in 2000 and the CO2 emissions (% of total fuel combustion) in Ecuador in 2002?
Give a very brief answer. 4.12. What is the difference between the CO2 emissions (% of total fuel combustion) of Other small states in 2000 and the CO2 emissions (% of total fuel combustion) of New Zealand in 2002?
Provide a short and direct response. 1.6. What is the difference between the CO2 emissions (% of total fuel combustion) in Other small states in 2000 and the CO2 emissions (% of total fuel combustion) in Yemen, Rep. in 2002?
Provide a succinct answer. -9.63. What is the difference between the CO2 emissions (% of total fuel combustion) in Ecuador in 2000 and the CO2 emissions (% of total fuel combustion) in New Zealand in 2002?
Make the answer very short. -4.06. What is the difference between the CO2 emissions (% of total fuel combustion) of Ecuador in 2000 and the CO2 emissions (% of total fuel combustion) of Yemen, Rep. in 2002?
Offer a terse response. -15.3. What is the difference between the CO2 emissions (% of total fuel combustion) of New Zealand in 2000 and the CO2 emissions (% of total fuel combustion) of Yemen, Rep. in 2002?
Provide a short and direct response. -11.43. What is the difference between the CO2 emissions (% of total fuel combustion) of Other small states in 2000 and the CO2 emissions (% of total fuel combustion) of Ecuador in 2003?
Provide a short and direct response. 3.92. What is the difference between the CO2 emissions (% of total fuel combustion) in Other small states in 2000 and the CO2 emissions (% of total fuel combustion) in New Zealand in 2003?
Make the answer very short. 1.41. What is the difference between the CO2 emissions (% of total fuel combustion) in Other small states in 2000 and the CO2 emissions (% of total fuel combustion) in Yemen, Rep. in 2003?
Offer a terse response. -9.06. What is the difference between the CO2 emissions (% of total fuel combustion) in Ecuador in 2000 and the CO2 emissions (% of total fuel combustion) in New Zealand in 2003?
Your answer should be very brief. -4.26. What is the difference between the CO2 emissions (% of total fuel combustion) of Ecuador in 2000 and the CO2 emissions (% of total fuel combustion) of Yemen, Rep. in 2003?
Ensure brevity in your answer.  -14.73. What is the difference between the CO2 emissions (% of total fuel combustion) of New Zealand in 2000 and the CO2 emissions (% of total fuel combustion) of Yemen, Rep. in 2003?
Give a very brief answer. -10.86. What is the difference between the CO2 emissions (% of total fuel combustion) of Other small states in 2000 and the CO2 emissions (% of total fuel combustion) of Ecuador in 2004?
Ensure brevity in your answer.  3.98. What is the difference between the CO2 emissions (% of total fuel combustion) of Other small states in 2000 and the CO2 emissions (% of total fuel combustion) of New Zealand in 2004?
Your answer should be very brief. 1.91. What is the difference between the CO2 emissions (% of total fuel combustion) of Other small states in 2000 and the CO2 emissions (% of total fuel combustion) of Yemen, Rep. in 2004?
Give a very brief answer. -9.87. What is the difference between the CO2 emissions (% of total fuel combustion) of Ecuador in 2000 and the CO2 emissions (% of total fuel combustion) of New Zealand in 2004?
Give a very brief answer. -3.76. What is the difference between the CO2 emissions (% of total fuel combustion) in Ecuador in 2000 and the CO2 emissions (% of total fuel combustion) in Yemen, Rep. in 2004?
Offer a very short reply. -15.54. What is the difference between the CO2 emissions (% of total fuel combustion) in New Zealand in 2000 and the CO2 emissions (% of total fuel combustion) in Yemen, Rep. in 2004?
Give a very brief answer. -11.67. What is the difference between the CO2 emissions (% of total fuel combustion) of Other small states in 2001 and the CO2 emissions (% of total fuel combustion) of Ecuador in 2002?
Keep it short and to the point. 6.28. What is the difference between the CO2 emissions (% of total fuel combustion) in Other small states in 2001 and the CO2 emissions (% of total fuel combustion) in New Zealand in 2002?
Your answer should be very brief. 3.77. What is the difference between the CO2 emissions (% of total fuel combustion) in Other small states in 2001 and the CO2 emissions (% of total fuel combustion) in Yemen, Rep. in 2002?
Your answer should be very brief. -7.46. What is the difference between the CO2 emissions (% of total fuel combustion) in Ecuador in 2001 and the CO2 emissions (% of total fuel combustion) in New Zealand in 2002?
Keep it short and to the point. -1.9. What is the difference between the CO2 emissions (% of total fuel combustion) in Ecuador in 2001 and the CO2 emissions (% of total fuel combustion) in Yemen, Rep. in 2002?
Your answer should be very brief. -13.14. What is the difference between the CO2 emissions (% of total fuel combustion) in New Zealand in 2001 and the CO2 emissions (% of total fuel combustion) in Yemen, Rep. in 2002?
Ensure brevity in your answer.  -11.68. What is the difference between the CO2 emissions (% of total fuel combustion) of Other small states in 2001 and the CO2 emissions (% of total fuel combustion) of Ecuador in 2003?
Make the answer very short. 6.08. What is the difference between the CO2 emissions (% of total fuel combustion) in Other small states in 2001 and the CO2 emissions (% of total fuel combustion) in New Zealand in 2003?
Your answer should be compact. 3.57. What is the difference between the CO2 emissions (% of total fuel combustion) of Other small states in 2001 and the CO2 emissions (% of total fuel combustion) of Yemen, Rep. in 2003?
Make the answer very short. -6.9. What is the difference between the CO2 emissions (% of total fuel combustion) in Ecuador in 2001 and the CO2 emissions (% of total fuel combustion) in New Zealand in 2003?
Ensure brevity in your answer.  -2.1. What is the difference between the CO2 emissions (% of total fuel combustion) in Ecuador in 2001 and the CO2 emissions (% of total fuel combustion) in Yemen, Rep. in 2003?
Your response must be concise. -12.57. What is the difference between the CO2 emissions (% of total fuel combustion) of New Zealand in 2001 and the CO2 emissions (% of total fuel combustion) of Yemen, Rep. in 2003?
Your answer should be very brief. -11.11. What is the difference between the CO2 emissions (% of total fuel combustion) of Other small states in 2001 and the CO2 emissions (% of total fuel combustion) of Ecuador in 2004?
Ensure brevity in your answer.  6.15. What is the difference between the CO2 emissions (% of total fuel combustion) of Other small states in 2001 and the CO2 emissions (% of total fuel combustion) of New Zealand in 2004?
Offer a very short reply. 4.08. What is the difference between the CO2 emissions (% of total fuel combustion) in Other small states in 2001 and the CO2 emissions (% of total fuel combustion) in Yemen, Rep. in 2004?
Keep it short and to the point. -7.7. What is the difference between the CO2 emissions (% of total fuel combustion) in Ecuador in 2001 and the CO2 emissions (% of total fuel combustion) in New Zealand in 2004?
Make the answer very short. -1.6. What is the difference between the CO2 emissions (% of total fuel combustion) in Ecuador in 2001 and the CO2 emissions (% of total fuel combustion) in Yemen, Rep. in 2004?
Offer a terse response. -13.38. What is the difference between the CO2 emissions (% of total fuel combustion) of New Zealand in 2001 and the CO2 emissions (% of total fuel combustion) of Yemen, Rep. in 2004?
Your answer should be very brief. -11.92. What is the difference between the CO2 emissions (% of total fuel combustion) in Other small states in 2002 and the CO2 emissions (% of total fuel combustion) in Ecuador in 2003?
Give a very brief answer. 5.17. What is the difference between the CO2 emissions (% of total fuel combustion) in Other small states in 2002 and the CO2 emissions (% of total fuel combustion) in New Zealand in 2003?
Your response must be concise. 2.66. What is the difference between the CO2 emissions (% of total fuel combustion) in Other small states in 2002 and the CO2 emissions (% of total fuel combustion) in Yemen, Rep. in 2003?
Ensure brevity in your answer.  -7.81. What is the difference between the CO2 emissions (% of total fuel combustion) in Ecuador in 2002 and the CO2 emissions (% of total fuel combustion) in New Zealand in 2003?
Ensure brevity in your answer.  -2.71. What is the difference between the CO2 emissions (% of total fuel combustion) of Ecuador in 2002 and the CO2 emissions (% of total fuel combustion) of Yemen, Rep. in 2003?
Make the answer very short. -13.18. What is the difference between the CO2 emissions (% of total fuel combustion) in New Zealand in 2002 and the CO2 emissions (% of total fuel combustion) in Yemen, Rep. in 2003?
Offer a terse response. -10.67. What is the difference between the CO2 emissions (% of total fuel combustion) of Other small states in 2002 and the CO2 emissions (% of total fuel combustion) of Ecuador in 2004?
Offer a very short reply. 5.23. What is the difference between the CO2 emissions (% of total fuel combustion) in Other small states in 2002 and the CO2 emissions (% of total fuel combustion) in New Zealand in 2004?
Provide a short and direct response. 3.16. What is the difference between the CO2 emissions (% of total fuel combustion) of Other small states in 2002 and the CO2 emissions (% of total fuel combustion) of Yemen, Rep. in 2004?
Offer a terse response. -8.62. What is the difference between the CO2 emissions (% of total fuel combustion) in Ecuador in 2002 and the CO2 emissions (% of total fuel combustion) in New Zealand in 2004?
Your response must be concise. -2.2. What is the difference between the CO2 emissions (% of total fuel combustion) of Ecuador in 2002 and the CO2 emissions (% of total fuel combustion) of Yemen, Rep. in 2004?
Offer a very short reply. -13.99. What is the difference between the CO2 emissions (% of total fuel combustion) of New Zealand in 2002 and the CO2 emissions (% of total fuel combustion) of Yemen, Rep. in 2004?
Provide a short and direct response. -11.48. What is the difference between the CO2 emissions (% of total fuel combustion) in Other small states in 2003 and the CO2 emissions (% of total fuel combustion) in Ecuador in 2004?
Your answer should be very brief. 5.47. What is the difference between the CO2 emissions (% of total fuel combustion) in Other small states in 2003 and the CO2 emissions (% of total fuel combustion) in New Zealand in 2004?
Provide a short and direct response. 3.4. What is the difference between the CO2 emissions (% of total fuel combustion) of Other small states in 2003 and the CO2 emissions (% of total fuel combustion) of Yemen, Rep. in 2004?
Offer a terse response. -8.38. What is the difference between the CO2 emissions (% of total fuel combustion) of Ecuador in 2003 and the CO2 emissions (% of total fuel combustion) of New Zealand in 2004?
Make the answer very short. -2.01. What is the difference between the CO2 emissions (% of total fuel combustion) of Ecuador in 2003 and the CO2 emissions (% of total fuel combustion) of Yemen, Rep. in 2004?
Provide a succinct answer. -13.79. What is the difference between the CO2 emissions (% of total fuel combustion) in New Zealand in 2003 and the CO2 emissions (% of total fuel combustion) in Yemen, Rep. in 2004?
Your response must be concise. -11.28. What is the average CO2 emissions (% of total fuel combustion) in Other small states per year?
Offer a very short reply. 7.97. What is the average CO2 emissions (% of total fuel combustion) in Ecuador per year?
Your response must be concise. 1.66. What is the average CO2 emissions (% of total fuel combustion) of New Zealand per year?
Provide a short and direct response. 5.03. What is the average CO2 emissions (% of total fuel combustion) in Yemen, Rep. per year?
Your answer should be very brief. 13.93. In the year 1997, what is the difference between the CO2 emissions (% of total fuel combustion) in Other small states and CO2 emissions (% of total fuel combustion) in Ecuador?
Ensure brevity in your answer.  8.14. In the year 1997, what is the difference between the CO2 emissions (% of total fuel combustion) of Other small states and CO2 emissions (% of total fuel combustion) of New Zealand?
Provide a succinct answer. 3.48. In the year 1997, what is the difference between the CO2 emissions (% of total fuel combustion) of Other small states and CO2 emissions (% of total fuel combustion) of Yemen, Rep.?
Offer a very short reply. -2.51. In the year 1997, what is the difference between the CO2 emissions (% of total fuel combustion) in Ecuador and CO2 emissions (% of total fuel combustion) in New Zealand?
Offer a terse response. -4.66. In the year 1997, what is the difference between the CO2 emissions (% of total fuel combustion) of Ecuador and CO2 emissions (% of total fuel combustion) of Yemen, Rep.?
Offer a terse response. -10.65. In the year 1997, what is the difference between the CO2 emissions (% of total fuel combustion) of New Zealand and CO2 emissions (% of total fuel combustion) of Yemen, Rep.?
Provide a succinct answer. -5.99. In the year 1998, what is the difference between the CO2 emissions (% of total fuel combustion) in Other small states and CO2 emissions (% of total fuel combustion) in Ecuador?
Give a very brief answer. 7.54. In the year 1998, what is the difference between the CO2 emissions (% of total fuel combustion) in Other small states and CO2 emissions (% of total fuel combustion) in New Zealand?
Offer a very short reply. 2.54. In the year 1998, what is the difference between the CO2 emissions (% of total fuel combustion) in Other small states and CO2 emissions (% of total fuel combustion) in Yemen, Rep.?
Give a very brief answer. -4. In the year 1998, what is the difference between the CO2 emissions (% of total fuel combustion) of Ecuador and CO2 emissions (% of total fuel combustion) of New Zealand?
Make the answer very short. -5. In the year 1998, what is the difference between the CO2 emissions (% of total fuel combustion) in Ecuador and CO2 emissions (% of total fuel combustion) in Yemen, Rep.?
Give a very brief answer. -11.54. In the year 1998, what is the difference between the CO2 emissions (% of total fuel combustion) of New Zealand and CO2 emissions (% of total fuel combustion) of Yemen, Rep.?
Your response must be concise. -6.54. In the year 1999, what is the difference between the CO2 emissions (% of total fuel combustion) in Other small states and CO2 emissions (% of total fuel combustion) in Ecuador?
Keep it short and to the point. 6.71. In the year 1999, what is the difference between the CO2 emissions (% of total fuel combustion) of Other small states and CO2 emissions (% of total fuel combustion) of New Zealand?
Keep it short and to the point. 1.82. In the year 1999, what is the difference between the CO2 emissions (% of total fuel combustion) of Other small states and CO2 emissions (% of total fuel combustion) of Yemen, Rep.?
Keep it short and to the point. -5.3. In the year 1999, what is the difference between the CO2 emissions (% of total fuel combustion) in Ecuador and CO2 emissions (% of total fuel combustion) in New Zealand?
Offer a terse response. -4.89. In the year 1999, what is the difference between the CO2 emissions (% of total fuel combustion) in Ecuador and CO2 emissions (% of total fuel combustion) in Yemen, Rep.?
Your answer should be compact. -12.01. In the year 1999, what is the difference between the CO2 emissions (% of total fuel combustion) in New Zealand and CO2 emissions (% of total fuel combustion) in Yemen, Rep.?
Your answer should be very brief. -7.12. In the year 2000, what is the difference between the CO2 emissions (% of total fuel combustion) in Other small states and CO2 emissions (% of total fuel combustion) in Ecuador?
Offer a very short reply. 5.67. In the year 2000, what is the difference between the CO2 emissions (% of total fuel combustion) of Other small states and CO2 emissions (% of total fuel combustion) of New Zealand?
Provide a succinct answer. 1.8. In the year 2000, what is the difference between the CO2 emissions (% of total fuel combustion) in Other small states and CO2 emissions (% of total fuel combustion) in Yemen, Rep.?
Your response must be concise. -6.97. In the year 2000, what is the difference between the CO2 emissions (% of total fuel combustion) in Ecuador and CO2 emissions (% of total fuel combustion) in New Zealand?
Make the answer very short. -3.87. In the year 2000, what is the difference between the CO2 emissions (% of total fuel combustion) of Ecuador and CO2 emissions (% of total fuel combustion) of Yemen, Rep.?
Your response must be concise. -12.64. In the year 2000, what is the difference between the CO2 emissions (% of total fuel combustion) in New Zealand and CO2 emissions (% of total fuel combustion) in Yemen, Rep.?
Offer a very short reply. -8.77. In the year 2001, what is the difference between the CO2 emissions (% of total fuel combustion) in Other small states and CO2 emissions (% of total fuel combustion) in Ecuador?
Provide a short and direct response. 5.67. In the year 2001, what is the difference between the CO2 emissions (% of total fuel combustion) of Other small states and CO2 emissions (% of total fuel combustion) of New Zealand?
Ensure brevity in your answer.  4.22. In the year 2001, what is the difference between the CO2 emissions (% of total fuel combustion) in Other small states and CO2 emissions (% of total fuel combustion) in Yemen, Rep.?
Your response must be concise. -5.09. In the year 2001, what is the difference between the CO2 emissions (% of total fuel combustion) in Ecuador and CO2 emissions (% of total fuel combustion) in New Zealand?
Your response must be concise. -1.46. In the year 2001, what is the difference between the CO2 emissions (% of total fuel combustion) of Ecuador and CO2 emissions (% of total fuel combustion) of Yemen, Rep.?
Keep it short and to the point. -10.76. In the year 2001, what is the difference between the CO2 emissions (% of total fuel combustion) in New Zealand and CO2 emissions (% of total fuel combustion) in Yemen, Rep.?
Ensure brevity in your answer.  -9.3. In the year 2002, what is the difference between the CO2 emissions (% of total fuel combustion) of Other small states and CO2 emissions (% of total fuel combustion) of Ecuador?
Offer a terse response. 5.37. In the year 2002, what is the difference between the CO2 emissions (% of total fuel combustion) of Other small states and CO2 emissions (% of total fuel combustion) of New Zealand?
Provide a short and direct response. 2.85. In the year 2002, what is the difference between the CO2 emissions (% of total fuel combustion) in Other small states and CO2 emissions (% of total fuel combustion) in Yemen, Rep.?
Offer a very short reply. -8.38. In the year 2002, what is the difference between the CO2 emissions (% of total fuel combustion) in Ecuador and CO2 emissions (% of total fuel combustion) in New Zealand?
Your answer should be compact. -2.51. In the year 2002, what is the difference between the CO2 emissions (% of total fuel combustion) of Ecuador and CO2 emissions (% of total fuel combustion) of Yemen, Rep.?
Your answer should be very brief. -13.75. In the year 2002, what is the difference between the CO2 emissions (% of total fuel combustion) in New Zealand and CO2 emissions (% of total fuel combustion) in Yemen, Rep.?
Provide a short and direct response. -11.24. In the year 2003, what is the difference between the CO2 emissions (% of total fuel combustion) of Other small states and CO2 emissions (% of total fuel combustion) of Ecuador?
Your answer should be compact. 5.41. In the year 2003, what is the difference between the CO2 emissions (% of total fuel combustion) of Other small states and CO2 emissions (% of total fuel combustion) of New Zealand?
Your answer should be very brief. 2.9. In the year 2003, what is the difference between the CO2 emissions (% of total fuel combustion) in Other small states and CO2 emissions (% of total fuel combustion) in Yemen, Rep.?
Offer a very short reply. -7.57. In the year 2003, what is the difference between the CO2 emissions (% of total fuel combustion) of Ecuador and CO2 emissions (% of total fuel combustion) of New Zealand?
Provide a succinct answer. -2.51. In the year 2003, what is the difference between the CO2 emissions (% of total fuel combustion) in Ecuador and CO2 emissions (% of total fuel combustion) in Yemen, Rep.?
Keep it short and to the point. -12.98. In the year 2003, what is the difference between the CO2 emissions (% of total fuel combustion) of New Zealand and CO2 emissions (% of total fuel combustion) of Yemen, Rep.?
Give a very brief answer. -10.47. In the year 2004, what is the difference between the CO2 emissions (% of total fuel combustion) of Other small states and CO2 emissions (% of total fuel combustion) of Ecuador?
Your answer should be compact. 5.97. In the year 2004, what is the difference between the CO2 emissions (% of total fuel combustion) of Other small states and CO2 emissions (% of total fuel combustion) of New Zealand?
Your response must be concise. 3.9. In the year 2004, what is the difference between the CO2 emissions (% of total fuel combustion) in Other small states and CO2 emissions (% of total fuel combustion) in Yemen, Rep.?
Your answer should be very brief. -7.88. In the year 2004, what is the difference between the CO2 emissions (% of total fuel combustion) in Ecuador and CO2 emissions (% of total fuel combustion) in New Zealand?
Make the answer very short. -2.07. In the year 2004, what is the difference between the CO2 emissions (% of total fuel combustion) of Ecuador and CO2 emissions (% of total fuel combustion) of Yemen, Rep.?
Ensure brevity in your answer.  -13.85. In the year 2004, what is the difference between the CO2 emissions (% of total fuel combustion) in New Zealand and CO2 emissions (% of total fuel combustion) in Yemen, Rep.?
Make the answer very short. -11.78. What is the ratio of the CO2 emissions (% of total fuel combustion) of Other small states in 1997 to that in 1998?
Make the answer very short. 1.09. What is the ratio of the CO2 emissions (% of total fuel combustion) of Ecuador in 1997 to that in 1998?
Offer a very short reply. 1.2. What is the ratio of the CO2 emissions (% of total fuel combustion) in New Zealand in 1997 to that in 1998?
Give a very brief answer. 0.95. What is the ratio of the CO2 emissions (% of total fuel combustion) of Yemen, Rep. in 1997 to that in 1998?
Ensure brevity in your answer.  0.93. What is the ratio of the CO2 emissions (% of total fuel combustion) of Other small states in 1997 to that in 1999?
Offer a very short reply. 1.22. What is the ratio of the CO2 emissions (% of total fuel combustion) of Ecuador in 1997 to that in 1999?
Ensure brevity in your answer.  1.37. What is the ratio of the CO2 emissions (% of total fuel combustion) in New Zealand in 1997 to that in 1999?
Make the answer very short. 0.98. What is the ratio of the CO2 emissions (% of total fuel combustion) of Yemen, Rep. in 1997 to that in 1999?
Your response must be concise. 0.9. What is the ratio of the CO2 emissions (% of total fuel combustion) in Other small states in 1997 to that in 2000?
Your answer should be very brief. 1.29. What is the ratio of the CO2 emissions (% of total fuel combustion) of Ecuador in 1997 to that in 2000?
Offer a very short reply. 0.47. What is the ratio of the CO2 emissions (% of total fuel combustion) in New Zealand in 1997 to that in 2000?
Provide a succinct answer. 1.06. What is the ratio of the CO2 emissions (% of total fuel combustion) of Yemen, Rep. in 1997 to that in 2000?
Make the answer very short. 0.82. What is the ratio of the CO2 emissions (% of total fuel combustion) in Other small states in 1997 to that in 2001?
Your answer should be compact. 0.98. What is the ratio of the CO2 emissions (% of total fuel combustion) of Ecuador in 1997 to that in 2001?
Your answer should be compact. 0.15. What is the ratio of the CO2 emissions (% of total fuel combustion) in New Zealand in 1997 to that in 2001?
Give a very brief answer. 1.11. What is the ratio of the CO2 emissions (% of total fuel combustion) of Yemen, Rep. in 1997 to that in 2001?
Give a very brief answer. 0.8. What is the ratio of the CO2 emissions (% of total fuel combustion) in Other small states in 1997 to that in 2002?
Keep it short and to the point. 1.09. What is the ratio of the CO2 emissions (% of total fuel combustion) in Ecuador in 1997 to that in 2002?
Keep it short and to the point. 0.18. What is the ratio of the CO2 emissions (% of total fuel combustion) of New Zealand in 1997 to that in 2002?
Keep it short and to the point. 1.02. What is the ratio of the CO2 emissions (% of total fuel combustion) of Yemen, Rep. in 1997 to that in 2002?
Provide a succinct answer. 0.68. What is the ratio of the CO2 emissions (% of total fuel combustion) of Other small states in 1997 to that in 2003?
Provide a succinct answer. 1.06. What is the ratio of the CO2 emissions (% of total fuel combustion) in Ecuador in 1997 to that in 2003?
Keep it short and to the point. 0.17. What is the ratio of the CO2 emissions (% of total fuel combustion) of New Zealand in 1997 to that in 2003?
Your response must be concise. 0.98. What is the ratio of the CO2 emissions (% of total fuel combustion) in Yemen, Rep. in 1997 to that in 2003?
Offer a very short reply. 0.71. What is the ratio of the CO2 emissions (% of total fuel combustion) of Other small states in 1997 to that in 2004?
Your answer should be very brief. 1. What is the ratio of the CO2 emissions (% of total fuel combustion) of Ecuador in 1997 to that in 2004?
Provide a succinct answer. 0.17. What is the ratio of the CO2 emissions (% of total fuel combustion) in New Zealand in 1997 to that in 2004?
Ensure brevity in your answer.  1.08. What is the ratio of the CO2 emissions (% of total fuel combustion) in Yemen, Rep. in 1997 to that in 2004?
Give a very brief answer. 0.67. What is the ratio of the CO2 emissions (% of total fuel combustion) of Other small states in 1998 to that in 1999?
Make the answer very short. 1.12. What is the ratio of the CO2 emissions (% of total fuel combustion) of Ecuador in 1998 to that in 1999?
Offer a terse response. 1.15. What is the ratio of the CO2 emissions (% of total fuel combustion) of New Zealand in 1998 to that in 1999?
Your answer should be compact. 1.03. What is the ratio of the CO2 emissions (% of total fuel combustion) of Yemen, Rep. in 1998 to that in 1999?
Offer a terse response. 0.97. What is the ratio of the CO2 emissions (% of total fuel combustion) of Other small states in 1998 to that in 2000?
Your answer should be very brief. 1.19. What is the ratio of the CO2 emissions (% of total fuel combustion) in Ecuador in 1998 to that in 2000?
Keep it short and to the point. 0.4. What is the ratio of the CO2 emissions (% of total fuel combustion) in New Zealand in 1998 to that in 2000?
Your answer should be very brief. 1.11. What is the ratio of the CO2 emissions (% of total fuel combustion) of Yemen, Rep. in 1998 to that in 2000?
Ensure brevity in your answer.  0.88. What is the ratio of the CO2 emissions (% of total fuel combustion) in Other small states in 1998 to that in 2001?
Your answer should be very brief. 0.9. What is the ratio of the CO2 emissions (% of total fuel combustion) of Ecuador in 1998 to that in 2001?
Provide a short and direct response. 0.12. What is the ratio of the CO2 emissions (% of total fuel combustion) of New Zealand in 1998 to that in 2001?
Offer a terse response. 1.17. What is the ratio of the CO2 emissions (% of total fuel combustion) of Yemen, Rep. in 1998 to that in 2001?
Ensure brevity in your answer.  0.86. What is the ratio of the CO2 emissions (% of total fuel combustion) in Ecuador in 1998 to that in 2002?
Keep it short and to the point. 0.15. What is the ratio of the CO2 emissions (% of total fuel combustion) of New Zealand in 1998 to that in 2002?
Offer a very short reply. 1.07. What is the ratio of the CO2 emissions (% of total fuel combustion) in Yemen, Rep. in 1998 to that in 2002?
Make the answer very short. 0.73. What is the ratio of the CO2 emissions (% of total fuel combustion) in Other small states in 1998 to that in 2003?
Provide a short and direct response. 0.97. What is the ratio of the CO2 emissions (% of total fuel combustion) in Ecuador in 1998 to that in 2003?
Your answer should be very brief. 0.14. What is the ratio of the CO2 emissions (% of total fuel combustion) of New Zealand in 1998 to that in 2003?
Make the answer very short. 1.03. What is the ratio of the CO2 emissions (% of total fuel combustion) of Yemen, Rep. in 1998 to that in 2003?
Your response must be concise. 0.76. What is the ratio of the CO2 emissions (% of total fuel combustion) of Other small states in 1998 to that in 2004?
Your answer should be compact. 0.92. What is the ratio of the CO2 emissions (% of total fuel combustion) in Ecuador in 1998 to that in 2004?
Offer a terse response. 0.15. What is the ratio of the CO2 emissions (% of total fuel combustion) of New Zealand in 1998 to that in 2004?
Your answer should be compact. 1.14. What is the ratio of the CO2 emissions (% of total fuel combustion) of Yemen, Rep. in 1998 to that in 2004?
Your answer should be very brief. 0.72. What is the ratio of the CO2 emissions (% of total fuel combustion) in Other small states in 1999 to that in 2000?
Keep it short and to the point. 1.06. What is the ratio of the CO2 emissions (% of total fuel combustion) of Ecuador in 1999 to that in 2000?
Make the answer very short. 0.34. What is the ratio of the CO2 emissions (% of total fuel combustion) in New Zealand in 1999 to that in 2000?
Your answer should be compact. 1.08. What is the ratio of the CO2 emissions (% of total fuel combustion) of Yemen, Rep. in 1999 to that in 2000?
Your answer should be very brief. 0.91. What is the ratio of the CO2 emissions (% of total fuel combustion) in Other small states in 1999 to that in 2001?
Give a very brief answer. 0.8. What is the ratio of the CO2 emissions (% of total fuel combustion) of Ecuador in 1999 to that in 2001?
Give a very brief answer. 0.11. What is the ratio of the CO2 emissions (% of total fuel combustion) of New Zealand in 1999 to that in 2001?
Your response must be concise. 1.14. What is the ratio of the CO2 emissions (% of total fuel combustion) of Yemen, Rep. in 1999 to that in 2001?
Your answer should be compact. 0.89. What is the ratio of the CO2 emissions (% of total fuel combustion) of Other small states in 1999 to that in 2002?
Ensure brevity in your answer.  0.89. What is the ratio of the CO2 emissions (% of total fuel combustion) in Ecuador in 1999 to that in 2002?
Your answer should be compact. 0.13. What is the ratio of the CO2 emissions (% of total fuel combustion) of New Zealand in 1999 to that in 2002?
Offer a terse response. 1.04. What is the ratio of the CO2 emissions (% of total fuel combustion) in Yemen, Rep. in 1999 to that in 2002?
Your response must be concise. 0.76. What is the ratio of the CO2 emissions (% of total fuel combustion) in Other small states in 1999 to that in 2003?
Give a very brief answer. 0.87. What is the ratio of the CO2 emissions (% of total fuel combustion) of Ecuador in 1999 to that in 2003?
Your answer should be compact. 0.12. What is the ratio of the CO2 emissions (% of total fuel combustion) in Yemen, Rep. in 1999 to that in 2003?
Provide a short and direct response. 0.79. What is the ratio of the CO2 emissions (% of total fuel combustion) in Other small states in 1999 to that in 2004?
Offer a very short reply. 0.82. What is the ratio of the CO2 emissions (% of total fuel combustion) in Ecuador in 1999 to that in 2004?
Ensure brevity in your answer.  0.13. What is the ratio of the CO2 emissions (% of total fuel combustion) in New Zealand in 1999 to that in 2004?
Provide a short and direct response. 1.1. What is the ratio of the CO2 emissions (% of total fuel combustion) of Yemen, Rep. in 1999 to that in 2004?
Keep it short and to the point. 0.75. What is the ratio of the CO2 emissions (% of total fuel combustion) of Other small states in 2000 to that in 2001?
Provide a short and direct response. 0.75. What is the ratio of the CO2 emissions (% of total fuel combustion) in Ecuador in 2000 to that in 2001?
Your answer should be compact. 0.31. What is the ratio of the CO2 emissions (% of total fuel combustion) of New Zealand in 2000 to that in 2001?
Provide a short and direct response. 1.05. What is the ratio of the CO2 emissions (% of total fuel combustion) in Yemen, Rep. in 2000 to that in 2001?
Provide a succinct answer. 0.98. What is the ratio of the CO2 emissions (% of total fuel combustion) of Other small states in 2000 to that in 2002?
Offer a terse response. 0.84. What is the ratio of the CO2 emissions (% of total fuel combustion) in Ecuador in 2000 to that in 2002?
Provide a short and direct response. 0.39. What is the ratio of the CO2 emissions (% of total fuel combustion) of New Zealand in 2000 to that in 2002?
Give a very brief answer. 0.96. What is the ratio of the CO2 emissions (% of total fuel combustion) of Yemen, Rep. in 2000 to that in 2002?
Make the answer very short. 0.84. What is the ratio of the CO2 emissions (% of total fuel combustion) in Other small states in 2000 to that in 2003?
Your answer should be very brief. 0.82. What is the ratio of the CO2 emissions (% of total fuel combustion) in Ecuador in 2000 to that in 2003?
Ensure brevity in your answer.  0.36. What is the ratio of the CO2 emissions (% of total fuel combustion) of New Zealand in 2000 to that in 2003?
Give a very brief answer. 0.93. What is the ratio of the CO2 emissions (% of total fuel combustion) in Yemen, Rep. in 2000 to that in 2003?
Provide a short and direct response. 0.87. What is the ratio of the CO2 emissions (% of total fuel combustion) of Other small states in 2000 to that in 2004?
Offer a terse response. 0.77. What is the ratio of the CO2 emissions (% of total fuel combustion) in Ecuador in 2000 to that in 2004?
Your answer should be compact. 0.37. What is the ratio of the CO2 emissions (% of total fuel combustion) of New Zealand in 2000 to that in 2004?
Offer a terse response. 1.02. What is the ratio of the CO2 emissions (% of total fuel combustion) in Yemen, Rep. in 2000 to that in 2004?
Your response must be concise. 0.82. What is the ratio of the CO2 emissions (% of total fuel combustion) of Other small states in 2001 to that in 2002?
Ensure brevity in your answer.  1.12. What is the ratio of the CO2 emissions (% of total fuel combustion) in Ecuador in 2001 to that in 2002?
Keep it short and to the point. 1.24. What is the ratio of the CO2 emissions (% of total fuel combustion) in New Zealand in 2001 to that in 2002?
Provide a succinct answer. 0.91. What is the ratio of the CO2 emissions (% of total fuel combustion) of Yemen, Rep. in 2001 to that in 2002?
Keep it short and to the point. 0.85. What is the ratio of the CO2 emissions (% of total fuel combustion) in Other small states in 2001 to that in 2003?
Provide a succinct answer. 1.08. What is the ratio of the CO2 emissions (% of total fuel combustion) of Ecuador in 2001 to that in 2003?
Your answer should be compact. 1.15. What is the ratio of the CO2 emissions (% of total fuel combustion) of New Zealand in 2001 to that in 2003?
Keep it short and to the point. 0.88. What is the ratio of the CO2 emissions (% of total fuel combustion) of Yemen, Rep. in 2001 to that in 2003?
Give a very brief answer. 0.88. What is the ratio of the CO2 emissions (% of total fuel combustion) of Other small states in 2001 to that in 2004?
Give a very brief answer. 1.02. What is the ratio of the CO2 emissions (% of total fuel combustion) of Ecuador in 2001 to that in 2004?
Provide a short and direct response. 1.18. What is the ratio of the CO2 emissions (% of total fuel combustion) in New Zealand in 2001 to that in 2004?
Your answer should be very brief. 0.97. What is the ratio of the CO2 emissions (% of total fuel combustion) of Yemen, Rep. in 2001 to that in 2004?
Provide a succinct answer. 0.84. What is the ratio of the CO2 emissions (% of total fuel combustion) of Other small states in 2002 to that in 2003?
Make the answer very short. 0.97. What is the ratio of the CO2 emissions (% of total fuel combustion) in Ecuador in 2002 to that in 2003?
Ensure brevity in your answer.  0.93. What is the ratio of the CO2 emissions (% of total fuel combustion) in New Zealand in 2002 to that in 2003?
Keep it short and to the point. 0.96. What is the ratio of the CO2 emissions (% of total fuel combustion) in Yemen, Rep. in 2002 to that in 2003?
Offer a very short reply. 1.04. What is the ratio of the CO2 emissions (% of total fuel combustion) in Other small states in 2002 to that in 2004?
Provide a short and direct response. 0.91. What is the ratio of the CO2 emissions (% of total fuel combustion) in Ecuador in 2002 to that in 2004?
Offer a terse response. 0.95. What is the ratio of the CO2 emissions (% of total fuel combustion) in New Zealand in 2002 to that in 2004?
Give a very brief answer. 1.06. What is the ratio of the CO2 emissions (% of total fuel combustion) in Yemen, Rep. in 2002 to that in 2004?
Your answer should be very brief. 0.99. What is the ratio of the CO2 emissions (% of total fuel combustion) in Other small states in 2003 to that in 2004?
Provide a short and direct response. 0.94. What is the ratio of the CO2 emissions (% of total fuel combustion) in Ecuador in 2003 to that in 2004?
Your response must be concise. 1.02. What is the ratio of the CO2 emissions (% of total fuel combustion) in New Zealand in 2003 to that in 2004?
Your response must be concise. 1.11. What is the ratio of the CO2 emissions (% of total fuel combustion) of Yemen, Rep. in 2003 to that in 2004?
Give a very brief answer. 0.95. What is the difference between the highest and the second highest CO2 emissions (% of total fuel combustion) of Other small states?
Make the answer very short. 0.18. What is the difference between the highest and the second highest CO2 emissions (% of total fuel combustion) in Ecuador?
Your answer should be very brief. 0.41. What is the difference between the highest and the second highest CO2 emissions (% of total fuel combustion) of New Zealand?
Ensure brevity in your answer.  0.15. What is the difference between the highest and the second highest CO2 emissions (% of total fuel combustion) of Yemen, Rep.?
Provide a succinct answer. 0.24. What is the difference between the highest and the lowest CO2 emissions (% of total fuel combustion) of Other small states?
Keep it short and to the point. 2.17. What is the difference between the highest and the lowest CO2 emissions (% of total fuel combustion) of Ecuador?
Make the answer very short. 2.81. What is the difference between the highest and the lowest CO2 emissions (% of total fuel combustion) of New Zealand?
Your answer should be very brief. 0.79. What is the difference between the highest and the lowest CO2 emissions (% of total fuel combustion) of Yemen, Rep.?
Provide a short and direct response. 5.4. 